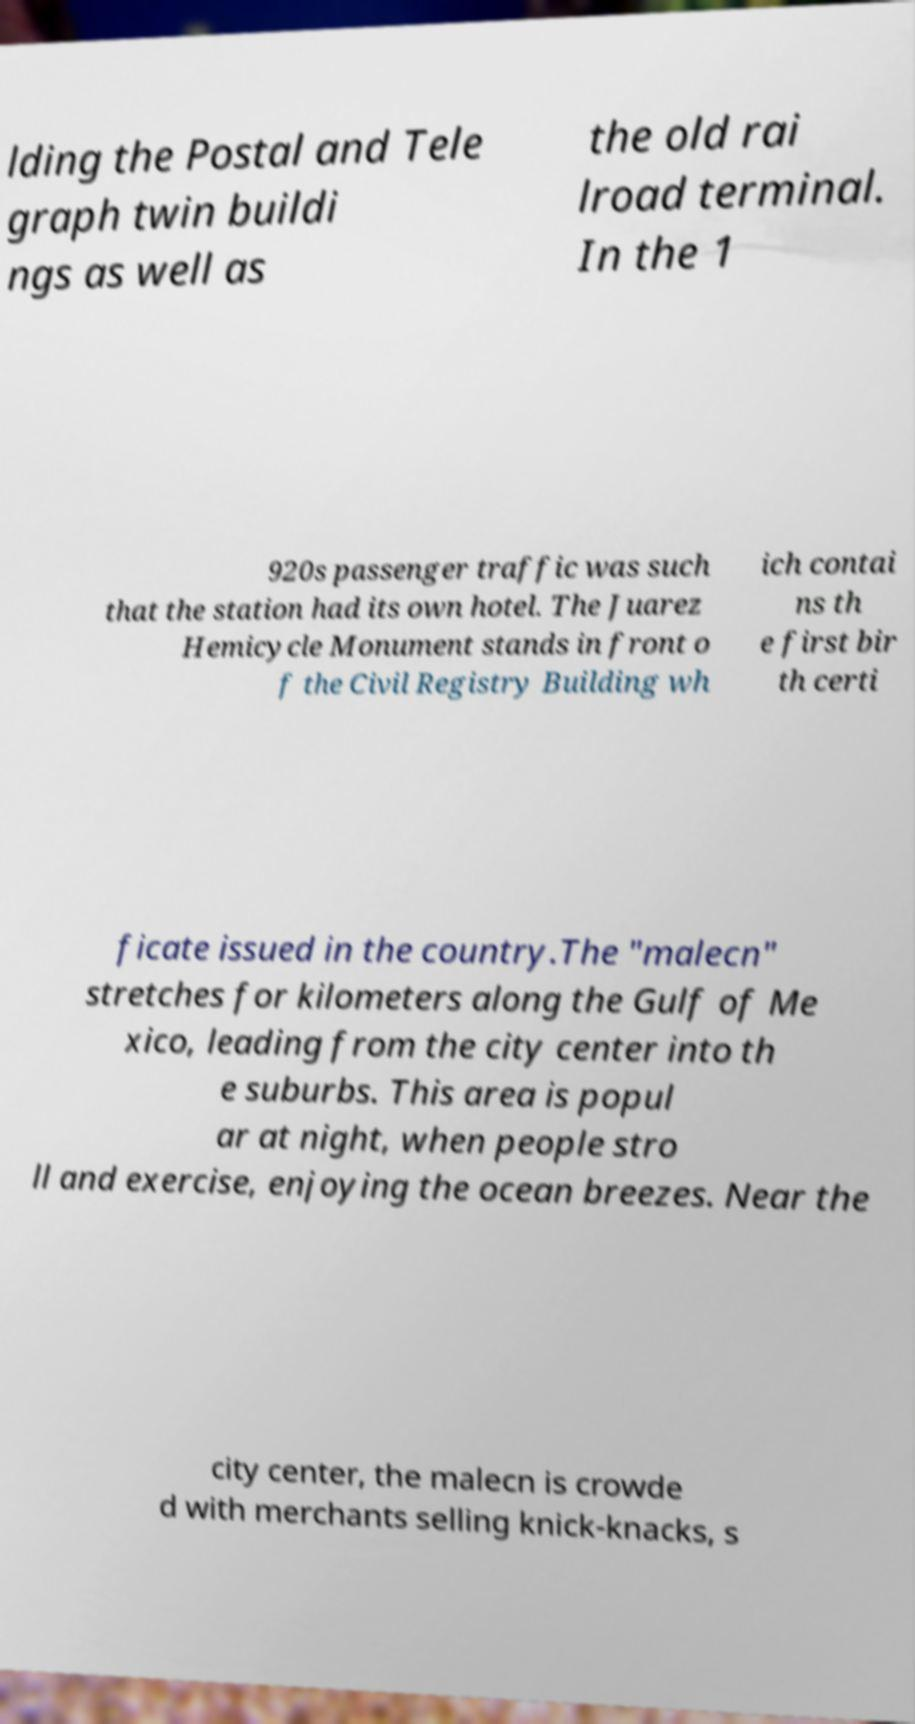There's text embedded in this image that I need extracted. Can you transcribe it verbatim? lding the Postal and Tele graph twin buildi ngs as well as the old rai lroad terminal. In the 1 920s passenger traffic was such that the station had its own hotel. The Juarez Hemicycle Monument stands in front o f the Civil Registry Building wh ich contai ns th e first bir th certi ficate issued in the country.The "malecn" stretches for kilometers along the Gulf of Me xico, leading from the city center into th e suburbs. This area is popul ar at night, when people stro ll and exercise, enjoying the ocean breezes. Near the city center, the malecn is crowde d with merchants selling knick-knacks, s 